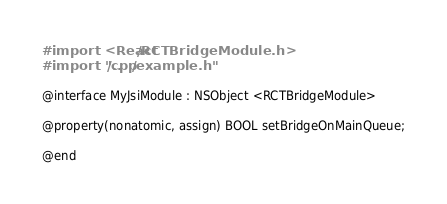<code> <loc_0><loc_0><loc_500><loc_500><_C_>#import <React/RCTBridgeModule.h>
#import "../cpp/example.h"

@interface MyJsiModule : NSObject <RCTBridgeModule>

@property(nonatomic, assign) BOOL setBridgeOnMainQueue;

@end
</code> 